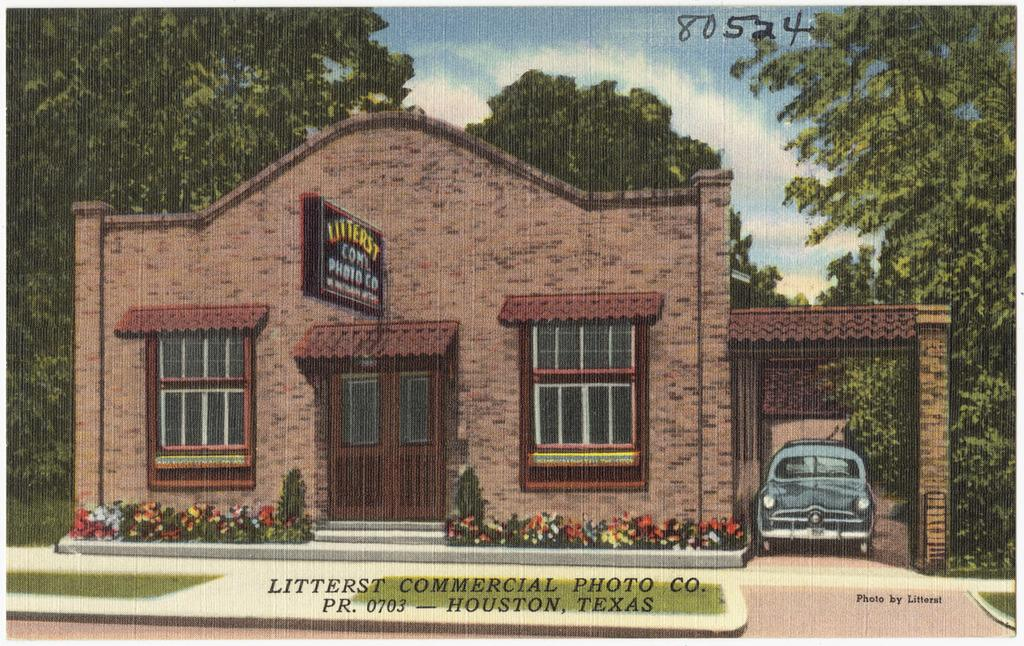What type of vegetation can be seen in the image? There is grass and flowering plants in the image. What type of structure is present in the image? There is a house in the image. What object can be seen in the image that might be used for displaying information or messages? There is a board in the image. What architectural feature can be seen in the house in the image? There are windows in the image. What type of transportation is visible in the image? There is a vehicle in the image. What type of natural feature can be seen in the image? There are trees in the image. What part of the natural environment is visible in the image? The sky is visible in the image. How is the image presented? The image appears to be a painting. What type of sign can be seen on the hill in the image? There is no hill or sign present in the image. What type of observation can be made about the vehicle in the image? The image does not provide enough information to make an observation about the vehicle. 